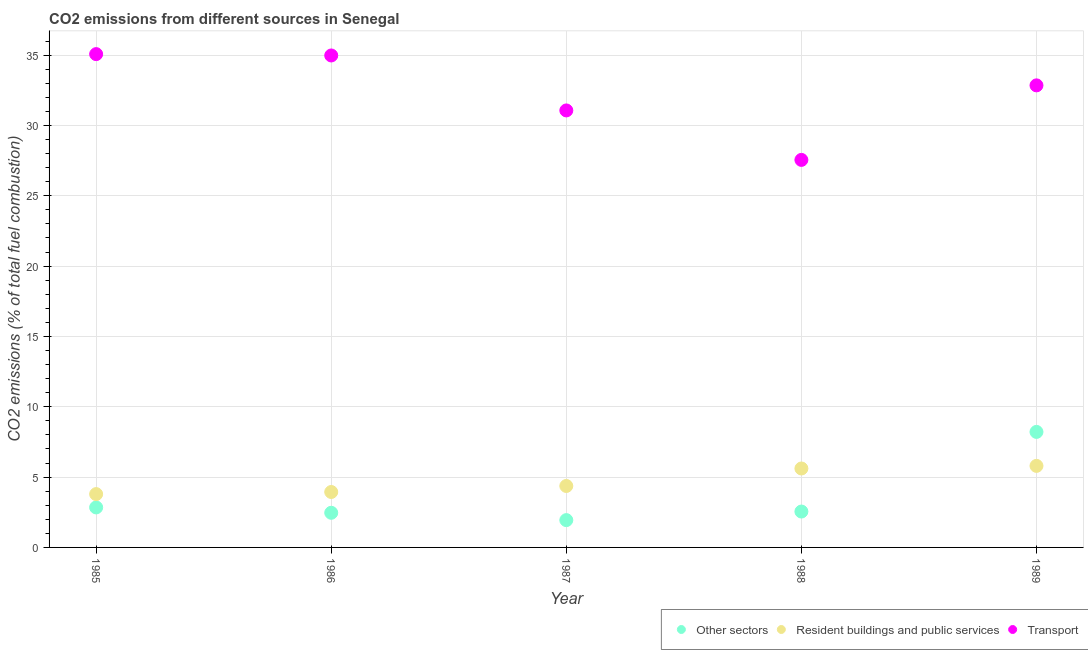What is the percentage of co2 emissions from other sectors in 1989?
Give a very brief answer. 8.21. Across all years, what is the maximum percentage of co2 emissions from resident buildings and public services?
Your response must be concise. 5.8. Across all years, what is the minimum percentage of co2 emissions from transport?
Keep it short and to the point. 27.55. In which year was the percentage of co2 emissions from transport minimum?
Your answer should be compact. 1988. What is the total percentage of co2 emissions from resident buildings and public services in the graph?
Offer a terse response. 23.51. What is the difference between the percentage of co2 emissions from resident buildings and public services in 1985 and that in 1986?
Offer a very short reply. -0.15. What is the difference between the percentage of co2 emissions from transport in 1985 and the percentage of co2 emissions from other sectors in 1989?
Give a very brief answer. 26.86. What is the average percentage of co2 emissions from transport per year?
Make the answer very short. 32.3. In the year 1987, what is the difference between the percentage of co2 emissions from resident buildings and public services and percentage of co2 emissions from transport?
Provide a short and direct response. -26.7. What is the ratio of the percentage of co2 emissions from other sectors in 1986 to that in 1988?
Ensure brevity in your answer.  0.97. Is the percentage of co2 emissions from resident buildings and public services in 1986 less than that in 1989?
Offer a terse response. Yes. What is the difference between the highest and the second highest percentage of co2 emissions from transport?
Offer a terse response. 0.1. What is the difference between the highest and the lowest percentage of co2 emissions from resident buildings and public services?
Make the answer very short. 2.01. In how many years, is the percentage of co2 emissions from resident buildings and public services greater than the average percentage of co2 emissions from resident buildings and public services taken over all years?
Ensure brevity in your answer.  2. Is it the case that in every year, the sum of the percentage of co2 emissions from other sectors and percentage of co2 emissions from resident buildings and public services is greater than the percentage of co2 emissions from transport?
Provide a succinct answer. No. Is the percentage of co2 emissions from other sectors strictly less than the percentage of co2 emissions from transport over the years?
Your answer should be very brief. Yes. How many dotlines are there?
Keep it short and to the point. 3. How many years are there in the graph?
Ensure brevity in your answer.  5. What is the difference between two consecutive major ticks on the Y-axis?
Your response must be concise. 5. Are the values on the major ticks of Y-axis written in scientific E-notation?
Your response must be concise. No. Does the graph contain grids?
Ensure brevity in your answer.  Yes. Where does the legend appear in the graph?
Give a very brief answer. Bottom right. How many legend labels are there?
Keep it short and to the point. 3. How are the legend labels stacked?
Offer a very short reply. Horizontal. What is the title of the graph?
Make the answer very short. CO2 emissions from different sources in Senegal. What is the label or title of the Y-axis?
Give a very brief answer. CO2 emissions (% of total fuel combustion). What is the CO2 emissions (% of total fuel combustion) of Other sectors in 1985?
Your answer should be very brief. 2.84. What is the CO2 emissions (% of total fuel combustion) of Resident buildings and public services in 1985?
Ensure brevity in your answer.  3.79. What is the CO2 emissions (% of total fuel combustion) of Transport in 1985?
Provide a short and direct response. 35.07. What is the CO2 emissions (% of total fuel combustion) of Other sectors in 1986?
Make the answer very short. 2.46. What is the CO2 emissions (% of total fuel combustion) in Resident buildings and public services in 1986?
Ensure brevity in your answer.  3.94. What is the CO2 emissions (% of total fuel combustion) of Transport in 1986?
Offer a very short reply. 34.98. What is the CO2 emissions (% of total fuel combustion) in Other sectors in 1987?
Offer a terse response. 1.94. What is the CO2 emissions (% of total fuel combustion) of Resident buildings and public services in 1987?
Ensure brevity in your answer.  4.37. What is the CO2 emissions (% of total fuel combustion) of Transport in 1987?
Your answer should be compact. 31.07. What is the CO2 emissions (% of total fuel combustion) of Other sectors in 1988?
Your answer should be compact. 2.55. What is the CO2 emissions (% of total fuel combustion) in Resident buildings and public services in 1988?
Offer a terse response. 5.61. What is the CO2 emissions (% of total fuel combustion) in Transport in 1988?
Give a very brief answer. 27.55. What is the CO2 emissions (% of total fuel combustion) in Other sectors in 1989?
Your response must be concise. 8.21. What is the CO2 emissions (% of total fuel combustion) in Resident buildings and public services in 1989?
Offer a very short reply. 5.8. What is the CO2 emissions (% of total fuel combustion) in Transport in 1989?
Provide a succinct answer. 32.85. Across all years, what is the maximum CO2 emissions (% of total fuel combustion) in Other sectors?
Your answer should be compact. 8.21. Across all years, what is the maximum CO2 emissions (% of total fuel combustion) in Resident buildings and public services?
Your response must be concise. 5.8. Across all years, what is the maximum CO2 emissions (% of total fuel combustion) in Transport?
Provide a short and direct response. 35.07. Across all years, what is the minimum CO2 emissions (% of total fuel combustion) in Other sectors?
Your response must be concise. 1.94. Across all years, what is the minimum CO2 emissions (% of total fuel combustion) in Resident buildings and public services?
Your answer should be compact. 3.79. Across all years, what is the minimum CO2 emissions (% of total fuel combustion) in Transport?
Provide a short and direct response. 27.55. What is the total CO2 emissions (% of total fuel combustion) in Other sectors in the graph?
Provide a succinct answer. 18.01. What is the total CO2 emissions (% of total fuel combustion) in Resident buildings and public services in the graph?
Provide a succinct answer. 23.51. What is the total CO2 emissions (% of total fuel combustion) of Transport in the graph?
Keep it short and to the point. 161.52. What is the difference between the CO2 emissions (% of total fuel combustion) of Other sectors in 1985 and that in 1986?
Offer a very short reply. 0.38. What is the difference between the CO2 emissions (% of total fuel combustion) in Resident buildings and public services in 1985 and that in 1986?
Give a very brief answer. -0.15. What is the difference between the CO2 emissions (% of total fuel combustion) of Transport in 1985 and that in 1986?
Your answer should be very brief. 0.1. What is the difference between the CO2 emissions (% of total fuel combustion) of Other sectors in 1985 and that in 1987?
Your answer should be very brief. 0.9. What is the difference between the CO2 emissions (% of total fuel combustion) in Resident buildings and public services in 1985 and that in 1987?
Provide a succinct answer. -0.58. What is the difference between the CO2 emissions (% of total fuel combustion) in Transport in 1985 and that in 1987?
Your response must be concise. 4. What is the difference between the CO2 emissions (% of total fuel combustion) in Other sectors in 1985 and that in 1988?
Provide a succinct answer. 0.29. What is the difference between the CO2 emissions (% of total fuel combustion) of Resident buildings and public services in 1985 and that in 1988?
Your answer should be compact. -1.82. What is the difference between the CO2 emissions (% of total fuel combustion) of Transport in 1985 and that in 1988?
Your response must be concise. 7.52. What is the difference between the CO2 emissions (% of total fuel combustion) of Other sectors in 1985 and that in 1989?
Offer a very short reply. -5.37. What is the difference between the CO2 emissions (% of total fuel combustion) of Resident buildings and public services in 1985 and that in 1989?
Make the answer very short. -2.01. What is the difference between the CO2 emissions (% of total fuel combustion) in Transport in 1985 and that in 1989?
Make the answer very short. 2.22. What is the difference between the CO2 emissions (% of total fuel combustion) in Other sectors in 1986 and that in 1987?
Offer a very short reply. 0.52. What is the difference between the CO2 emissions (% of total fuel combustion) of Resident buildings and public services in 1986 and that in 1987?
Your answer should be compact. -0.43. What is the difference between the CO2 emissions (% of total fuel combustion) of Transport in 1986 and that in 1987?
Make the answer very short. 3.91. What is the difference between the CO2 emissions (% of total fuel combustion) in Other sectors in 1986 and that in 1988?
Your answer should be compact. -0.09. What is the difference between the CO2 emissions (% of total fuel combustion) in Resident buildings and public services in 1986 and that in 1988?
Provide a succinct answer. -1.67. What is the difference between the CO2 emissions (% of total fuel combustion) of Transport in 1986 and that in 1988?
Ensure brevity in your answer.  7.42. What is the difference between the CO2 emissions (% of total fuel combustion) of Other sectors in 1986 and that in 1989?
Your answer should be compact. -5.75. What is the difference between the CO2 emissions (% of total fuel combustion) in Resident buildings and public services in 1986 and that in 1989?
Make the answer very short. -1.86. What is the difference between the CO2 emissions (% of total fuel combustion) in Transport in 1986 and that in 1989?
Offer a terse response. 2.13. What is the difference between the CO2 emissions (% of total fuel combustion) of Other sectors in 1987 and that in 1988?
Give a very brief answer. -0.61. What is the difference between the CO2 emissions (% of total fuel combustion) of Resident buildings and public services in 1987 and that in 1988?
Keep it short and to the point. -1.24. What is the difference between the CO2 emissions (% of total fuel combustion) of Transport in 1987 and that in 1988?
Give a very brief answer. 3.52. What is the difference between the CO2 emissions (% of total fuel combustion) of Other sectors in 1987 and that in 1989?
Give a very brief answer. -6.27. What is the difference between the CO2 emissions (% of total fuel combustion) of Resident buildings and public services in 1987 and that in 1989?
Make the answer very short. -1.43. What is the difference between the CO2 emissions (% of total fuel combustion) of Transport in 1987 and that in 1989?
Your answer should be very brief. -1.78. What is the difference between the CO2 emissions (% of total fuel combustion) of Other sectors in 1988 and that in 1989?
Make the answer very short. -5.66. What is the difference between the CO2 emissions (% of total fuel combustion) in Resident buildings and public services in 1988 and that in 1989?
Keep it short and to the point. -0.18. What is the difference between the CO2 emissions (% of total fuel combustion) in Transport in 1988 and that in 1989?
Provide a short and direct response. -5.3. What is the difference between the CO2 emissions (% of total fuel combustion) in Other sectors in 1985 and the CO2 emissions (% of total fuel combustion) in Resident buildings and public services in 1986?
Your answer should be very brief. -1.1. What is the difference between the CO2 emissions (% of total fuel combustion) in Other sectors in 1985 and the CO2 emissions (% of total fuel combustion) in Transport in 1986?
Keep it short and to the point. -32.13. What is the difference between the CO2 emissions (% of total fuel combustion) in Resident buildings and public services in 1985 and the CO2 emissions (% of total fuel combustion) in Transport in 1986?
Your answer should be compact. -31.18. What is the difference between the CO2 emissions (% of total fuel combustion) in Other sectors in 1985 and the CO2 emissions (% of total fuel combustion) in Resident buildings and public services in 1987?
Make the answer very short. -1.53. What is the difference between the CO2 emissions (% of total fuel combustion) in Other sectors in 1985 and the CO2 emissions (% of total fuel combustion) in Transport in 1987?
Offer a terse response. -28.22. What is the difference between the CO2 emissions (% of total fuel combustion) in Resident buildings and public services in 1985 and the CO2 emissions (% of total fuel combustion) in Transport in 1987?
Make the answer very short. -27.28. What is the difference between the CO2 emissions (% of total fuel combustion) in Other sectors in 1985 and the CO2 emissions (% of total fuel combustion) in Resident buildings and public services in 1988?
Keep it short and to the point. -2.77. What is the difference between the CO2 emissions (% of total fuel combustion) of Other sectors in 1985 and the CO2 emissions (% of total fuel combustion) of Transport in 1988?
Provide a short and direct response. -24.71. What is the difference between the CO2 emissions (% of total fuel combustion) in Resident buildings and public services in 1985 and the CO2 emissions (% of total fuel combustion) in Transport in 1988?
Provide a succinct answer. -23.76. What is the difference between the CO2 emissions (% of total fuel combustion) of Other sectors in 1985 and the CO2 emissions (% of total fuel combustion) of Resident buildings and public services in 1989?
Provide a succinct answer. -2.95. What is the difference between the CO2 emissions (% of total fuel combustion) in Other sectors in 1985 and the CO2 emissions (% of total fuel combustion) in Transport in 1989?
Keep it short and to the point. -30.01. What is the difference between the CO2 emissions (% of total fuel combustion) of Resident buildings and public services in 1985 and the CO2 emissions (% of total fuel combustion) of Transport in 1989?
Make the answer very short. -29.06. What is the difference between the CO2 emissions (% of total fuel combustion) in Other sectors in 1986 and the CO2 emissions (% of total fuel combustion) in Resident buildings and public services in 1987?
Offer a very short reply. -1.91. What is the difference between the CO2 emissions (% of total fuel combustion) of Other sectors in 1986 and the CO2 emissions (% of total fuel combustion) of Transport in 1987?
Provide a short and direct response. -28.6. What is the difference between the CO2 emissions (% of total fuel combustion) of Resident buildings and public services in 1986 and the CO2 emissions (% of total fuel combustion) of Transport in 1987?
Your answer should be very brief. -27.13. What is the difference between the CO2 emissions (% of total fuel combustion) of Other sectors in 1986 and the CO2 emissions (% of total fuel combustion) of Resident buildings and public services in 1988?
Offer a very short reply. -3.15. What is the difference between the CO2 emissions (% of total fuel combustion) of Other sectors in 1986 and the CO2 emissions (% of total fuel combustion) of Transport in 1988?
Your answer should be very brief. -25.09. What is the difference between the CO2 emissions (% of total fuel combustion) of Resident buildings and public services in 1986 and the CO2 emissions (% of total fuel combustion) of Transport in 1988?
Give a very brief answer. -23.61. What is the difference between the CO2 emissions (% of total fuel combustion) in Other sectors in 1986 and the CO2 emissions (% of total fuel combustion) in Resident buildings and public services in 1989?
Your answer should be very brief. -3.33. What is the difference between the CO2 emissions (% of total fuel combustion) of Other sectors in 1986 and the CO2 emissions (% of total fuel combustion) of Transport in 1989?
Offer a very short reply. -30.39. What is the difference between the CO2 emissions (% of total fuel combustion) in Resident buildings and public services in 1986 and the CO2 emissions (% of total fuel combustion) in Transport in 1989?
Keep it short and to the point. -28.91. What is the difference between the CO2 emissions (% of total fuel combustion) in Other sectors in 1987 and the CO2 emissions (% of total fuel combustion) in Resident buildings and public services in 1988?
Your response must be concise. -3.67. What is the difference between the CO2 emissions (% of total fuel combustion) of Other sectors in 1987 and the CO2 emissions (% of total fuel combustion) of Transport in 1988?
Your answer should be very brief. -25.61. What is the difference between the CO2 emissions (% of total fuel combustion) in Resident buildings and public services in 1987 and the CO2 emissions (% of total fuel combustion) in Transport in 1988?
Provide a succinct answer. -23.18. What is the difference between the CO2 emissions (% of total fuel combustion) of Other sectors in 1987 and the CO2 emissions (% of total fuel combustion) of Resident buildings and public services in 1989?
Your answer should be compact. -3.86. What is the difference between the CO2 emissions (% of total fuel combustion) of Other sectors in 1987 and the CO2 emissions (% of total fuel combustion) of Transport in 1989?
Offer a terse response. -30.91. What is the difference between the CO2 emissions (% of total fuel combustion) in Resident buildings and public services in 1987 and the CO2 emissions (% of total fuel combustion) in Transport in 1989?
Ensure brevity in your answer.  -28.48. What is the difference between the CO2 emissions (% of total fuel combustion) in Other sectors in 1988 and the CO2 emissions (% of total fuel combustion) in Resident buildings and public services in 1989?
Your answer should be compact. -3.25. What is the difference between the CO2 emissions (% of total fuel combustion) of Other sectors in 1988 and the CO2 emissions (% of total fuel combustion) of Transport in 1989?
Offer a very short reply. -30.3. What is the difference between the CO2 emissions (% of total fuel combustion) in Resident buildings and public services in 1988 and the CO2 emissions (% of total fuel combustion) in Transport in 1989?
Your response must be concise. -27.24. What is the average CO2 emissions (% of total fuel combustion) of Other sectors per year?
Give a very brief answer. 3.6. What is the average CO2 emissions (% of total fuel combustion) in Resident buildings and public services per year?
Offer a very short reply. 4.7. What is the average CO2 emissions (% of total fuel combustion) of Transport per year?
Your response must be concise. 32.3. In the year 1985, what is the difference between the CO2 emissions (% of total fuel combustion) of Other sectors and CO2 emissions (% of total fuel combustion) of Resident buildings and public services?
Provide a short and direct response. -0.95. In the year 1985, what is the difference between the CO2 emissions (% of total fuel combustion) in Other sectors and CO2 emissions (% of total fuel combustion) in Transport?
Your answer should be compact. -32.23. In the year 1985, what is the difference between the CO2 emissions (% of total fuel combustion) of Resident buildings and public services and CO2 emissions (% of total fuel combustion) of Transport?
Provide a succinct answer. -31.28. In the year 1986, what is the difference between the CO2 emissions (% of total fuel combustion) in Other sectors and CO2 emissions (% of total fuel combustion) in Resident buildings and public services?
Offer a terse response. -1.48. In the year 1986, what is the difference between the CO2 emissions (% of total fuel combustion) in Other sectors and CO2 emissions (% of total fuel combustion) in Transport?
Provide a short and direct response. -32.51. In the year 1986, what is the difference between the CO2 emissions (% of total fuel combustion) of Resident buildings and public services and CO2 emissions (% of total fuel combustion) of Transport?
Offer a very short reply. -31.03. In the year 1987, what is the difference between the CO2 emissions (% of total fuel combustion) of Other sectors and CO2 emissions (% of total fuel combustion) of Resident buildings and public services?
Offer a terse response. -2.43. In the year 1987, what is the difference between the CO2 emissions (% of total fuel combustion) of Other sectors and CO2 emissions (% of total fuel combustion) of Transport?
Ensure brevity in your answer.  -29.13. In the year 1987, what is the difference between the CO2 emissions (% of total fuel combustion) in Resident buildings and public services and CO2 emissions (% of total fuel combustion) in Transport?
Keep it short and to the point. -26.7. In the year 1988, what is the difference between the CO2 emissions (% of total fuel combustion) in Other sectors and CO2 emissions (% of total fuel combustion) in Resident buildings and public services?
Your answer should be very brief. -3.06. In the year 1988, what is the difference between the CO2 emissions (% of total fuel combustion) of Other sectors and CO2 emissions (% of total fuel combustion) of Transport?
Offer a very short reply. -25. In the year 1988, what is the difference between the CO2 emissions (% of total fuel combustion) in Resident buildings and public services and CO2 emissions (% of total fuel combustion) in Transport?
Your answer should be compact. -21.94. In the year 1989, what is the difference between the CO2 emissions (% of total fuel combustion) of Other sectors and CO2 emissions (% of total fuel combustion) of Resident buildings and public services?
Your answer should be very brief. 2.42. In the year 1989, what is the difference between the CO2 emissions (% of total fuel combustion) of Other sectors and CO2 emissions (% of total fuel combustion) of Transport?
Your response must be concise. -24.64. In the year 1989, what is the difference between the CO2 emissions (% of total fuel combustion) of Resident buildings and public services and CO2 emissions (% of total fuel combustion) of Transport?
Provide a short and direct response. -27.05. What is the ratio of the CO2 emissions (% of total fuel combustion) of Other sectors in 1985 to that in 1986?
Provide a succinct answer. 1.15. What is the ratio of the CO2 emissions (% of total fuel combustion) of Resident buildings and public services in 1985 to that in 1986?
Give a very brief answer. 0.96. What is the ratio of the CO2 emissions (% of total fuel combustion) of Transport in 1985 to that in 1986?
Provide a succinct answer. 1. What is the ratio of the CO2 emissions (% of total fuel combustion) in Other sectors in 1985 to that in 1987?
Give a very brief answer. 1.46. What is the ratio of the CO2 emissions (% of total fuel combustion) of Resident buildings and public services in 1985 to that in 1987?
Provide a succinct answer. 0.87. What is the ratio of the CO2 emissions (% of total fuel combustion) of Transport in 1985 to that in 1987?
Your response must be concise. 1.13. What is the ratio of the CO2 emissions (% of total fuel combustion) in Other sectors in 1985 to that in 1988?
Ensure brevity in your answer.  1.11. What is the ratio of the CO2 emissions (% of total fuel combustion) in Resident buildings and public services in 1985 to that in 1988?
Give a very brief answer. 0.68. What is the ratio of the CO2 emissions (% of total fuel combustion) of Transport in 1985 to that in 1988?
Your response must be concise. 1.27. What is the ratio of the CO2 emissions (% of total fuel combustion) of Other sectors in 1985 to that in 1989?
Your response must be concise. 0.35. What is the ratio of the CO2 emissions (% of total fuel combustion) of Resident buildings and public services in 1985 to that in 1989?
Ensure brevity in your answer.  0.65. What is the ratio of the CO2 emissions (% of total fuel combustion) of Transport in 1985 to that in 1989?
Give a very brief answer. 1.07. What is the ratio of the CO2 emissions (% of total fuel combustion) of Other sectors in 1986 to that in 1987?
Ensure brevity in your answer.  1.27. What is the ratio of the CO2 emissions (% of total fuel combustion) of Resident buildings and public services in 1986 to that in 1987?
Offer a very short reply. 0.9. What is the ratio of the CO2 emissions (% of total fuel combustion) of Transport in 1986 to that in 1987?
Your answer should be very brief. 1.13. What is the ratio of the CO2 emissions (% of total fuel combustion) of Other sectors in 1986 to that in 1988?
Offer a very short reply. 0.97. What is the ratio of the CO2 emissions (% of total fuel combustion) of Resident buildings and public services in 1986 to that in 1988?
Offer a very short reply. 0.7. What is the ratio of the CO2 emissions (% of total fuel combustion) in Transport in 1986 to that in 1988?
Make the answer very short. 1.27. What is the ratio of the CO2 emissions (% of total fuel combustion) in Other sectors in 1986 to that in 1989?
Provide a short and direct response. 0.3. What is the ratio of the CO2 emissions (% of total fuel combustion) of Resident buildings and public services in 1986 to that in 1989?
Keep it short and to the point. 0.68. What is the ratio of the CO2 emissions (% of total fuel combustion) in Transport in 1986 to that in 1989?
Make the answer very short. 1.06. What is the ratio of the CO2 emissions (% of total fuel combustion) in Other sectors in 1987 to that in 1988?
Your response must be concise. 0.76. What is the ratio of the CO2 emissions (% of total fuel combustion) of Resident buildings and public services in 1987 to that in 1988?
Your response must be concise. 0.78. What is the ratio of the CO2 emissions (% of total fuel combustion) of Transport in 1987 to that in 1988?
Provide a succinct answer. 1.13. What is the ratio of the CO2 emissions (% of total fuel combustion) in Other sectors in 1987 to that in 1989?
Your answer should be very brief. 0.24. What is the ratio of the CO2 emissions (% of total fuel combustion) of Resident buildings and public services in 1987 to that in 1989?
Ensure brevity in your answer.  0.75. What is the ratio of the CO2 emissions (% of total fuel combustion) in Transport in 1987 to that in 1989?
Offer a terse response. 0.95. What is the ratio of the CO2 emissions (% of total fuel combustion) in Other sectors in 1988 to that in 1989?
Give a very brief answer. 0.31. What is the ratio of the CO2 emissions (% of total fuel combustion) in Resident buildings and public services in 1988 to that in 1989?
Offer a very short reply. 0.97. What is the ratio of the CO2 emissions (% of total fuel combustion) in Transport in 1988 to that in 1989?
Give a very brief answer. 0.84. What is the difference between the highest and the second highest CO2 emissions (% of total fuel combustion) of Other sectors?
Your answer should be very brief. 5.37. What is the difference between the highest and the second highest CO2 emissions (% of total fuel combustion) in Resident buildings and public services?
Your response must be concise. 0.18. What is the difference between the highest and the second highest CO2 emissions (% of total fuel combustion) of Transport?
Your response must be concise. 0.1. What is the difference between the highest and the lowest CO2 emissions (% of total fuel combustion) of Other sectors?
Make the answer very short. 6.27. What is the difference between the highest and the lowest CO2 emissions (% of total fuel combustion) of Resident buildings and public services?
Provide a short and direct response. 2.01. What is the difference between the highest and the lowest CO2 emissions (% of total fuel combustion) in Transport?
Your answer should be compact. 7.52. 